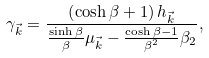<formula> <loc_0><loc_0><loc_500><loc_500>\gamma _ { \vec { k } } = \frac { \left ( \cosh \beta + 1 \right ) h _ { \vec { k } } } { \frac { \sinh \beta } { \beta } \mu _ { \vec { k } } - \frac { \cosh \beta - 1 } { \beta ^ { 2 } } \beta _ { 2 } } ,</formula> 